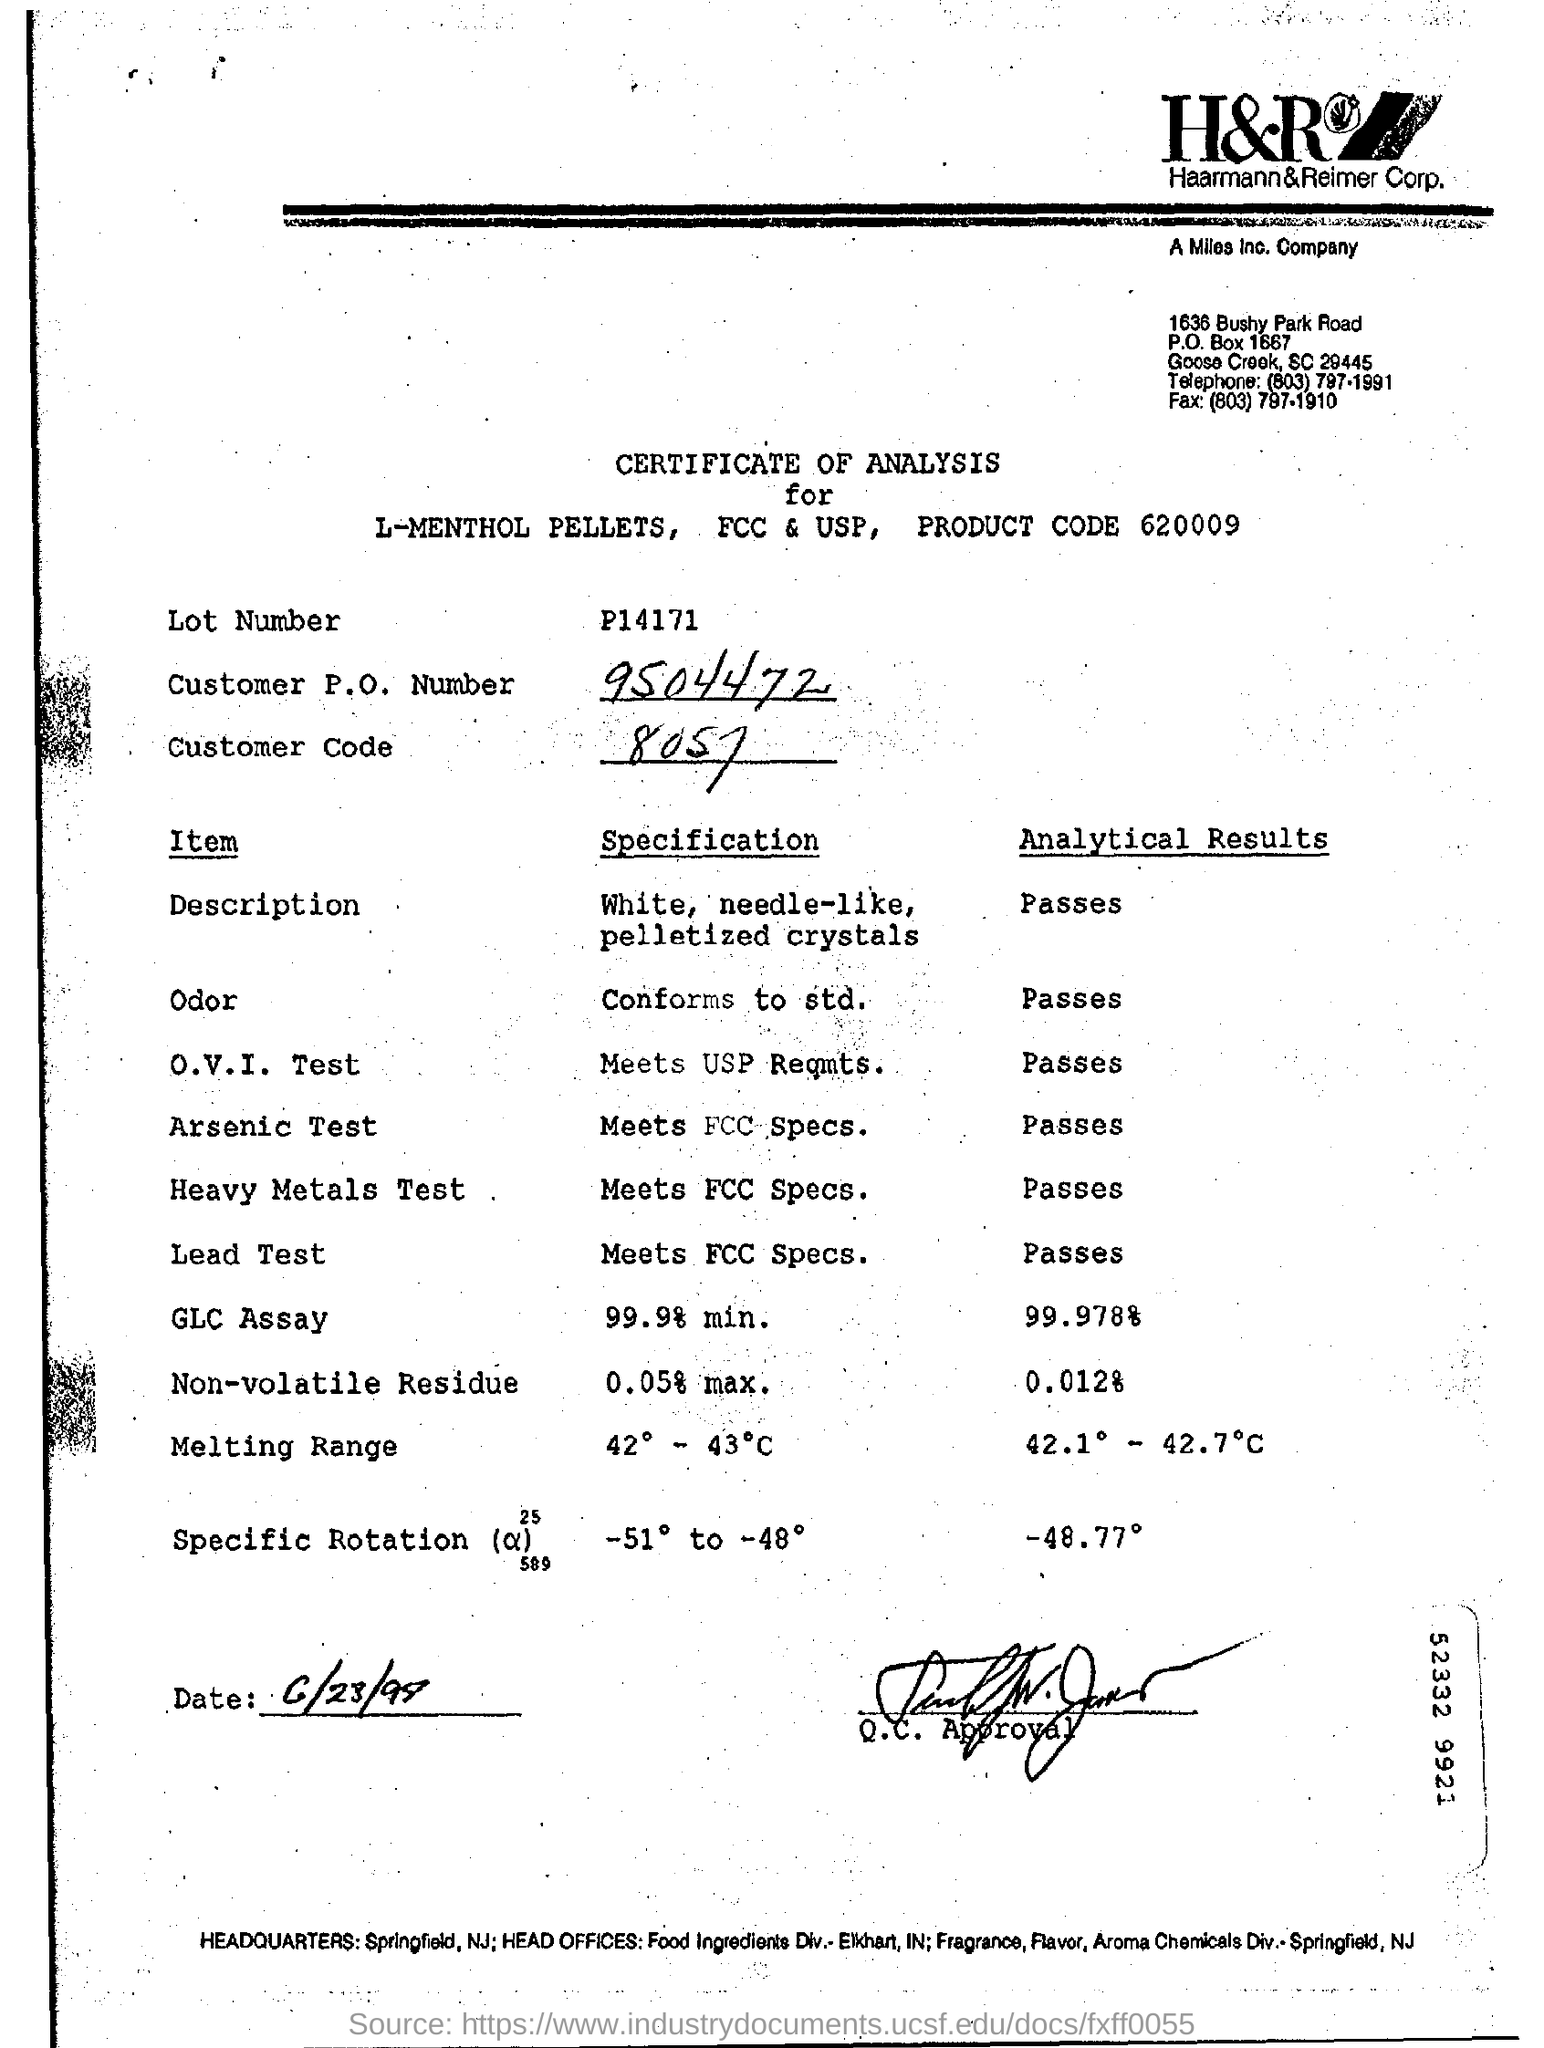Find customer code?
Offer a very short reply. 8057. What is customer P.O Number?
Your response must be concise. 9504472. 